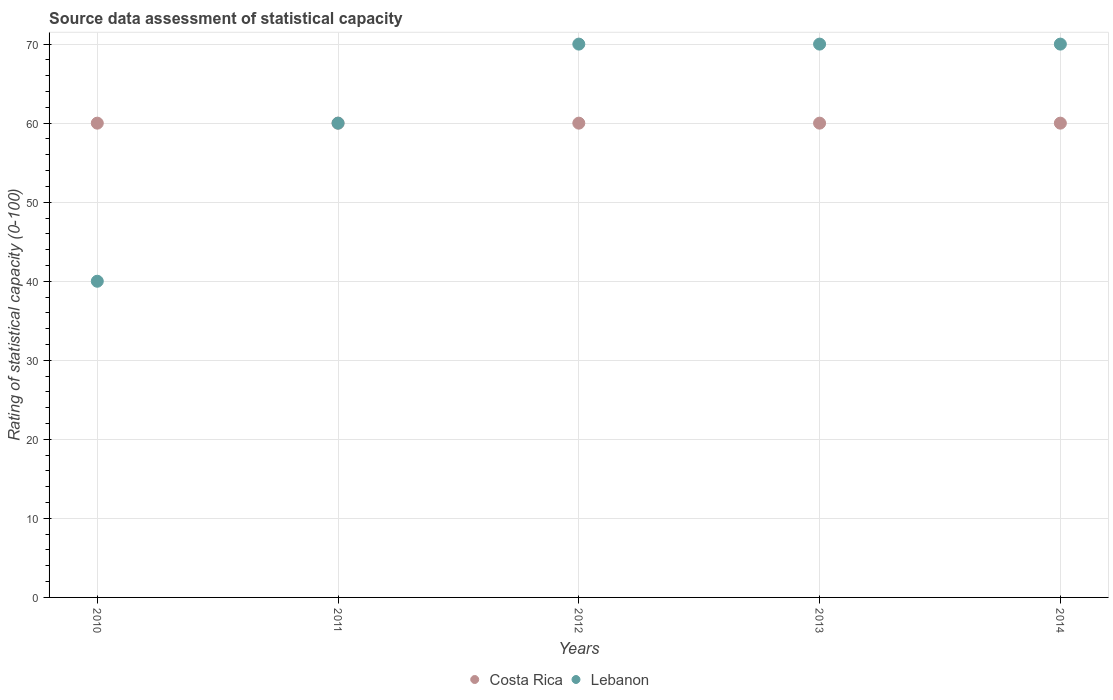What is the rating of statistical capacity in Lebanon in 2010?
Ensure brevity in your answer.  40. Across all years, what is the maximum rating of statistical capacity in Lebanon?
Your answer should be compact. 70. Across all years, what is the minimum rating of statistical capacity in Lebanon?
Offer a terse response. 40. In which year was the rating of statistical capacity in Costa Rica maximum?
Offer a terse response. 2010. In which year was the rating of statistical capacity in Costa Rica minimum?
Your answer should be compact. 2010. What is the total rating of statistical capacity in Lebanon in the graph?
Your answer should be very brief. 310. What is the difference between the rating of statistical capacity in Costa Rica in 2011 and the rating of statistical capacity in Lebanon in 2010?
Your answer should be very brief. 20. What is the average rating of statistical capacity in Lebanon per year?
Provide a short and direct response. 62. In the year 2014, what is the difference between the rating of statistical capacity in Costa Rica and rating of statistical capacity in Lebanon?
Ensure brevity in your answer.  -10. In how many years, is the rating of statistical capacity in Costa Rica greater than 16?
Offer a terse response. 5. What is the ratio of the rating of statistical capacity in Costa Rica in 2013 to that in 2014?
Keep it short and to the point. 1. Is the difference between the rating of statistical capacity in Costa Rica in 2010 and 2012 greater than the difference between the rating of statistical capacity in Lebanon in 2010 and 2012?
Provide a succinct answer. Yes. What is the difference between the highest and the lowest rating of statistical capacity in Costa Rica?
Keep it short and to the point. 0. In how many years, is the rating of statistical capacity in Costa Rica greater than the average rating of statistical capacity in Costa Rica taken over all years?
Keep it short and to the point. 0. Is the sum of the rating of statistical capacity in Lebanon in 2012 and 2014 greater than the maximum rating of statistical capacity in Costa Rica across all years?
Your answer should be compact. Yes. How many years are there in the graph?
Ensure brevity in your answer.  5. Are the values on the major ticks of Y-axis written in scientific E-notation?
Make the answer very short. No. Does the graph contain any zero values?
Give a very brief answer. No. Where does the legend appear in the graph?
Your answer should be compact. Bottom center. What is the title of the graph?
Your answer should be very brief. Source data assessment of statistical capacity. What is the label or title of the X-axis?
Your response must be concise. Years. What is the label or title of the Y-axis?
Make the answer very short. Rating of statistical capacity (0-100). What is the Rating of statistical capacity (0-100) of Costa Rica in 2010?
Provide a succinct answer. 60. What is the Rating of statistical capacity (0-100) in Costa Rica in 2011?
Your response must be concise. 60. What is the Rating of statistical capacity (0-100) in Costa Rica in 2012?
Provide a succinct answer. 60. What is the Rating of statistical capacity (0-100) of Lebanon in 2013?
Keep it short and to the point. 70. What is the Rating of statistical capacity (0-100) in Costa Rica in 2014?
Your answer should be compact. 60. What is the Rating of statistical capacity (0-100) in Lebanon in 2014?
Offer a very short reply. 70. Across all years, what is the maximum Rating of statistical capacity (0-100) of Costa Rica?
Provide a short and direct response. 60. Across all years, what is the minimum Rating of statistical capacity (0-100) in Costa Rica?
Ensure brevity in your answer.  60. What is the total Rating of statistical capacity (0-100) of Costa Rica in the graph?
Make the answer very short. 300. What is the total Rating of statistical capacity (0-100) in Lebanon in the graph?
Ensure brevity in your answer.  310. What is the difference between the Rating of statistical capacity (0-100) of Costa Rica in 2011 and that in 2012?
Offer a very short reply. 0. What is the difference between the Rating of statistical capacity (0-100) of Lebanon in 2011 and that in 2013?
Give a very brief answer. -10. What is the difference between the Rating of statistical capacity (0-100) in Lebanon in 2011 and that in 2014?
Ensure brevity in your answer.  -10. What is the difference between the Rating of statistical capacity (0-100) in Costa Rica in 2012 and that in 2013?
Your answer should be very brief. 0. What is the difference between the Rating of statistical capacity (0-100) of Costa Rica in 2012 and that in 2014?
Your answer should be very brief. 0. What is the difference between the Rating of statistical capacity (0-100) of Lebanon in 2012 and that in 2014?
Make the answer very short. 0. What is the difference between the Rating of statistical capacity (0-100) in Lebanon in 2013 and that in 2014?
Provide a short and direct response. 0. What is the difference between the Rating of statistical capacity (0-100) of Costa Rica in 2010 and the Rating of statistical capacity (0-100) of Lebanon in 2012?
Make the answer very short. -10. What is the difference between the Rating of statistical capacity (0-100) in Costa Rica in 2010 and the Rating of statistical capacity (0-100) in Lebanon in 2014?
Offer a very short reply. -10. What is the difference between the Rating of statistical capacity (0-100) of Costa Rica in 2011 and the Rating of statistical capacity (0-100) of Lebanon in 2013?
Offer a terse response. -10. What is the difference between the Rating of statistical capacity (0-100) in Costa Rica in 2011 and the Rating of statistical capacity (0-100) in Lebanon in 2014?
Your answer should be compact. -10. What is the difference between the Rating of statistical capacity (0-100) in Costa Rica in 2012 and the Rating of statistical capacity (0-100) in Lebanon in 2013?
Your answer should be compact. -10. In the year 2010, what is the difference between the Rating of statistical capacity (0-100) in Costa Rica and Rating of statistical capacity (0-100) in Lebanon?
Provide a short and direct response. 20. In the year 2013, what is the difference between the Rating of statistical capacity (0-100) in Costa Rica and Rating of statistical capacity (0-100) in Lebanon?
Provide a short and direct response. -10. What is the ratio of the Rating of statistical capacity (0-100) of Costa Rica in 2010 to that in 2013?
Make the answer very short. 1. What is the ratio of the Rating of statistical capacity (0-100) in Lebanon in 2010 to that in 2013?
Give a very brief answer. 0.57. What is the ratio of the Rating of statistical capacity (0-100) of Costa Rica in 2010 to that in 2014?
Provide a succinct answer. 1. What is the ratio of the Rating of statistical capacity (0-100) of Lebanon in 2011 to that in 2012?
Keep it short and to the point. 0.86. What is the ratio of the Rating of statistical capacity (0-100) of Lebanon in 2011 to that in 2014?
Ensure brevity in your answer.  0.86. What is the ratio of the Rating of statistical capacity (0-100) of Costa Rica in 2012 to that in 2013?
Your answer should be compact. 1. What is the ratio of the Rating of statistical capacity (0-100) in Lebanon in 2012 to that in 2013?
Provide a succinct answer. 1. What is the ratio of the Rating of statistical capacity (0-100) of Costa Rica in 2012 to that in 2014?
Your answer should be compact. 1. What is the ratio of the Rating of statistical capacity (0-100) of Lebanon in 2012 to that in 2014?
Your answer should be compact. 1. What is the ratio of the Rating of statistical capacity (0-100) in Lebanon in 2013 to that in 2014?
Your answer should be compact. 1. 